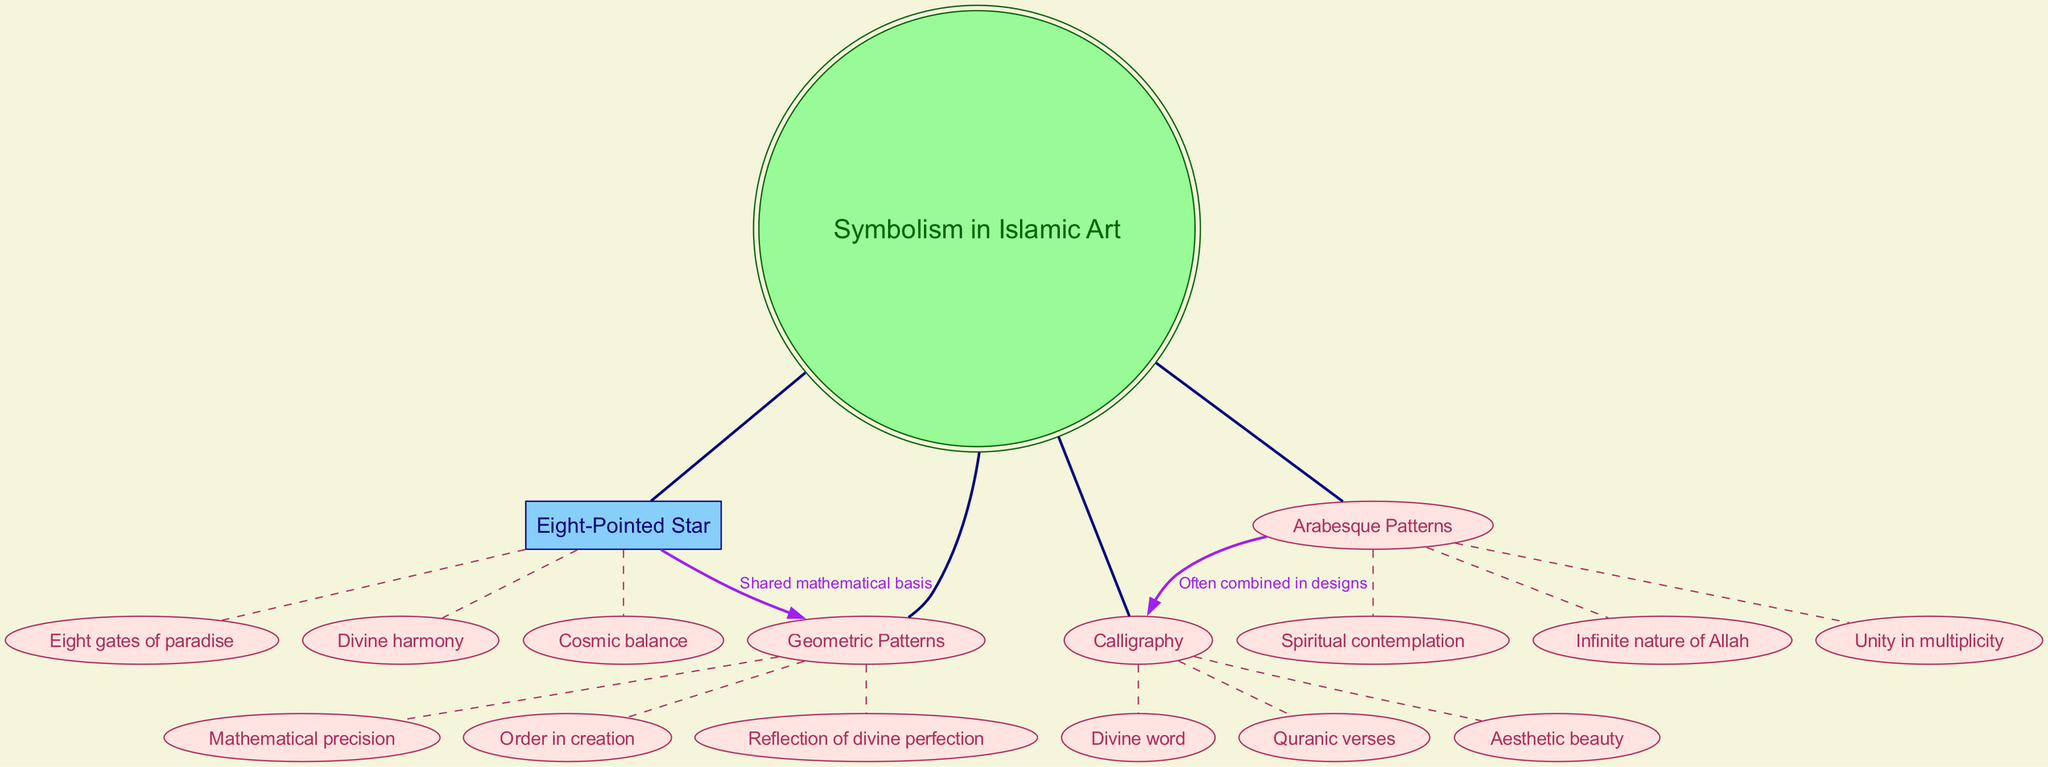What is the central topic of the diagram? The central topic is explicitly labeled in the diagram as "Symbolism in Islamic Art." This node is at the top center, making it easy to identify.
Answer: Symbolism in Islamic Art How many main branches are there in the diagram? There are four main branches branching out from the central topic. Each branch represents a different aspect of symbolism in Islamic art.
Answer: 4 What motif is associated with "Divine harmony"? "Divine harmony" is a sub-element under the main branch "Eight-Pointed Star." By following the lines from the central topic to this specific sub-element, the connection becomes clear.
Answer: Eight-Pointed Star Which two motifs are connected by a purple edge, and what is the label on that edge? The motifs "Eight-Pointed Star" and "Geometric Patterns" are connected by a purple edge that is labeled "Shared mathematical basis." This information can be found directly on the edge between these two nodes.
Answer: Eight-Pointed Star and Geometric Patterns, Shared mathematical basis How many sub-elements does the "Arabesque Patterns" branch have? The "Arabesque Patterns" branch contains three sub-elements: "Infinite nature of Allah," "Unity in multiplicity," and "Spiritual contemplation." Counting these sub-elements reveals the total number.
Answer: 3 What does the connection between "Arabesque Patterns" and "Calligraphy" represent? The connection between these two motifs is labeled "Often combined in designs," indicating that they frequently appear together in Islamic art. This relationship can be recognized from the diagram's connection label.
Answer: Often combined in designs What does the diagram indicate about the nature of "Geometric Patterns"? The sub-elements under "Geometric Patterns" include "Mathematical precision," "Order in creation," and "Reflection of divine perfection," suggesting that these concepts illustrate the essence of geometric patterns in Islamic art.
Answer: Mathematical precision, Order in creation, Reflection of divine perfection What is the visual shape of the nodes representing sub-elements in this diagram? The nodes representing sub-elements are shaped like ellipses as indicated by the node shape attributes specified in the diagram code. This characteristic can be observed in the diagram.
Answer: Ellipses In terms of content, how are "Calligraphy" and "Arabesque Patterns" related beyond their direct connection? Both aspects emphasize the aesthetic and spiritual significance in Islamic art, often contributing to a holistic representation in designs. This reasoning combines a broader understanding of their individual meanings and their combined representation in art.
Answer: Aesthetic and spiritual significance 